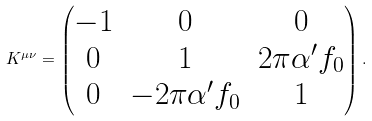<formula> <loc_0><loc_0><loc_500><loc_500>K ^ { \mu \nu } = \begin{pmatrix} - 1 & 0 & 0 \\ 0 & 1 & 2 \pi \alpha ^ { \prime } f _ { 0 } \\ 0 & - 2 \pi \alpha ^ { \prime } f _ { 0 } & 1 \end{pmatrix} .</formula> 